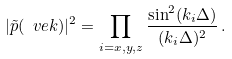<formula> <loc_0><loc_0><loc_500><loc_500>| \tilde { p } ( \ v e k ) | ^ { 2 } = \prod _ { i = x , y , z } \frac { \sin ^ { 2 } ( k _ { i } \Delta ) } { ( k _ { i } \Delta ) ^ { 2 } } \, .</formula> 